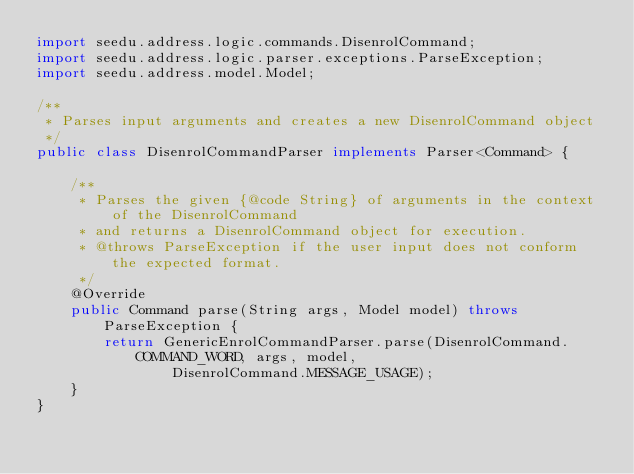<code> <loc_0><loc_0><loc_500><loc_500><_Java_>import seedu.address.logic.commands.DisenrolCommand;
import seedu.address.logic.parser.exceptions.ParseException;
import seedu.address.model.Model;

/**
 * Parses input arguments and creates a new DisenrolCommand object
 */
public class DisenrolCommandParser implements Parser<Command> {

    /**
     * Parses the given {@code String} of arguments in the context of the DisenrolCommand
     * and returns a DisenrolCommand object for execution.
     * @throws ParseException if the user input does not conform the expected format.
     */
    @Override
    public Command parse(String args, Model model) throws ParseException {
        return GenericEnrolCommandParser.parse(DisenrolCommand.COMMAND_WORD, args, model,
                DisenrolCommand.MESSAGE_USAGE);
    }
}
</code> 